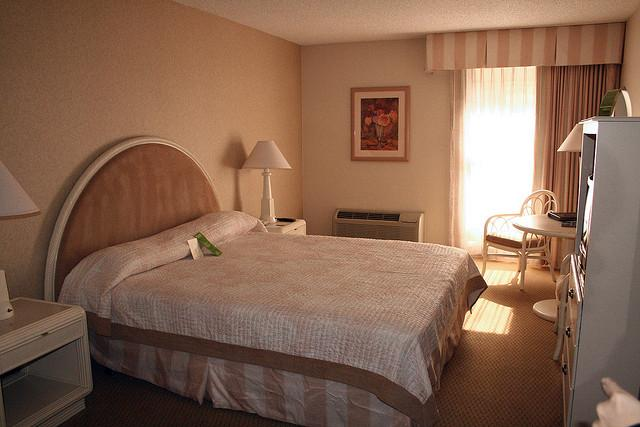What venue is shown here? Please explain your reasoning. hotel room. A large king bed with some pamphlets are located at top of bed. 